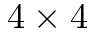<formula> <loc_0><loc_0><loc_500><loc_500>4 \times 4</formula> 